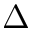<formula> <loc_0><loc_0><loc_500><loc_500>\Delta</formula> 